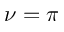<formula> <loc_0><loc_0><loc_500><loc_500>\nu = \pi</formula> 